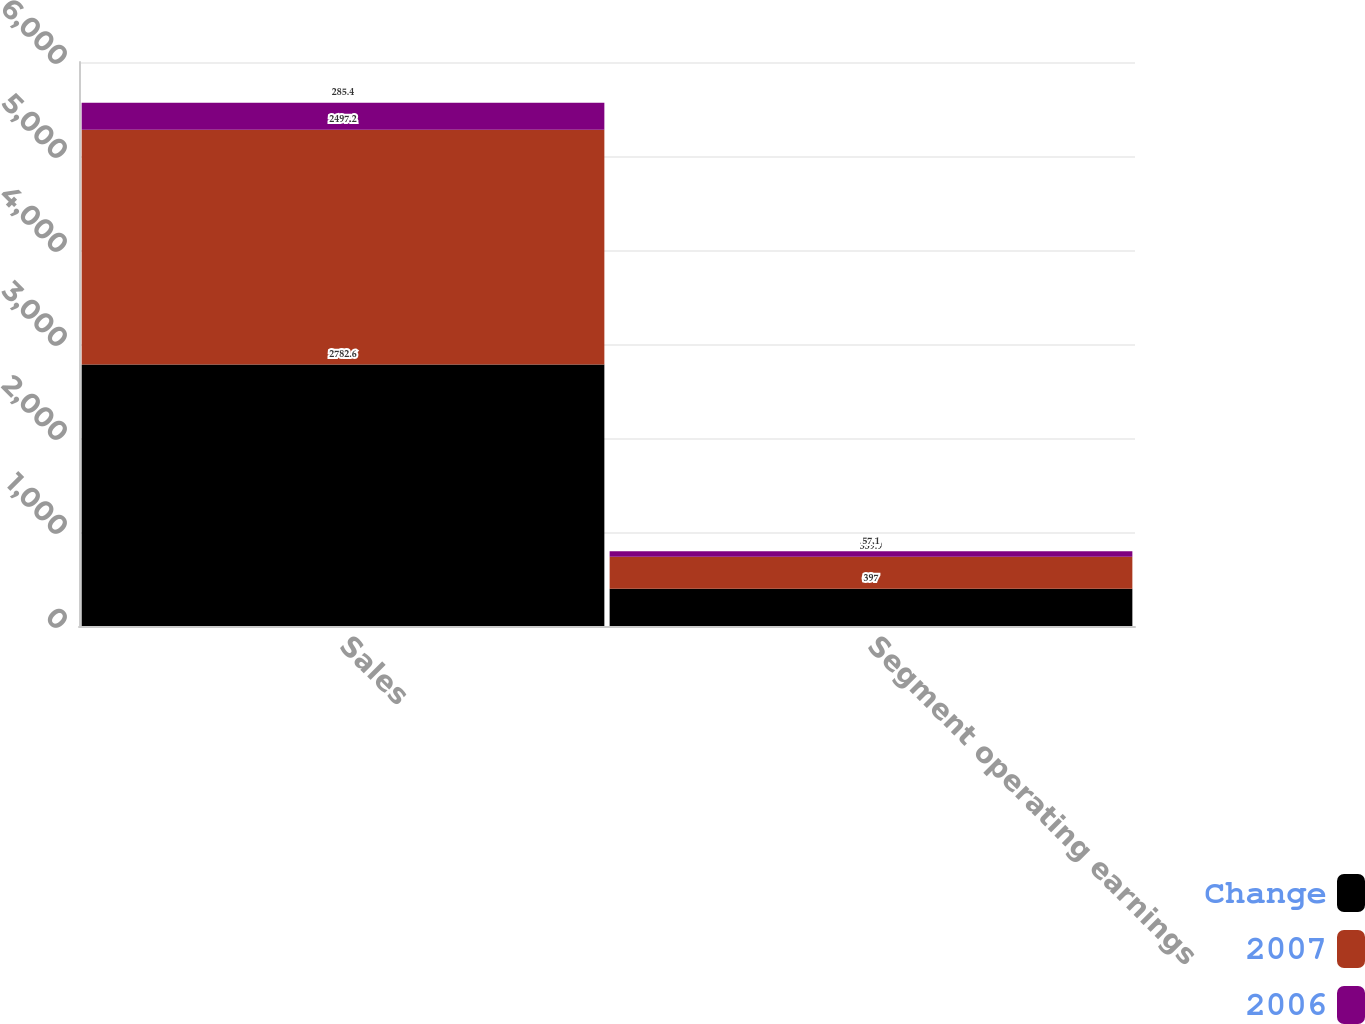<chart> <loc_0><loc_0><loc_500><loc_500><stacked_bar_chart><ecel><fcel>Sales<fcel>Segment operating earnings<nl><fcel>Change<fcel>2782.6<fcel>397<nl><fcel>2007<fcel>2497.2<fcel>339.9<nl><fcel>2006<fcel>285.4<fcel>57.1<nl></chart> 